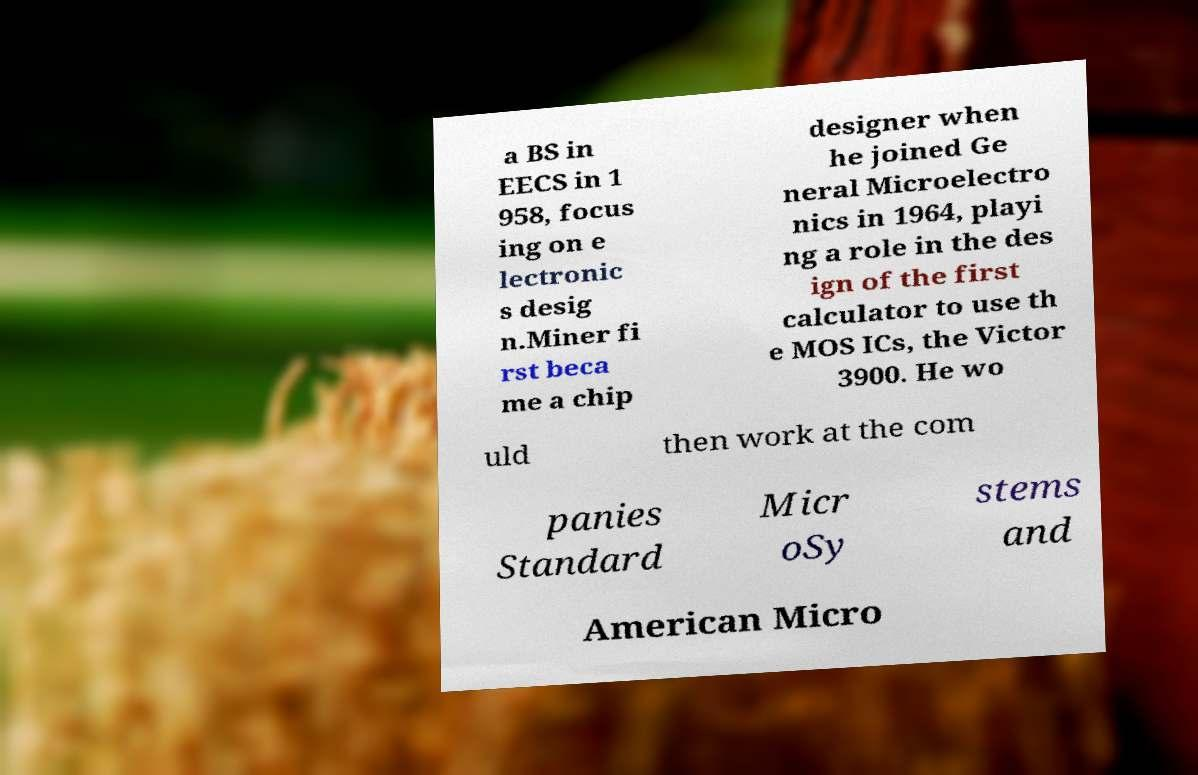Can you accurately transcribe the text from the provided image for me? a BS in EECS in 1 958, focus ing on e lectronic s desig n.Miner fi rst beca me a chip designer when he joined Ge neral Microelectro nics in 1964, playi ng a role in the des ign of the first calculator to use th e MOS ICs, the Victor 3900. He wo uld then work at the com panies Standard Micr oSy stems and American Micro 